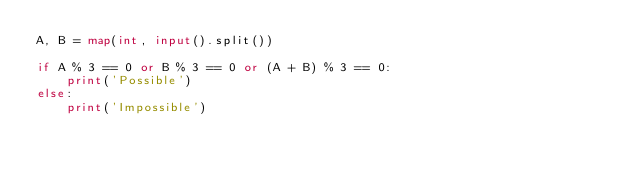<code> <loc_0><loc_0><loc_500><loc_500><_Python_>A, B = map(int, input().split())

if A % 3 == 0 or B % 3 == 0 or (A + B) % 3 == 0:
    print('Possible')
else:
    print('Impossible')</code> 